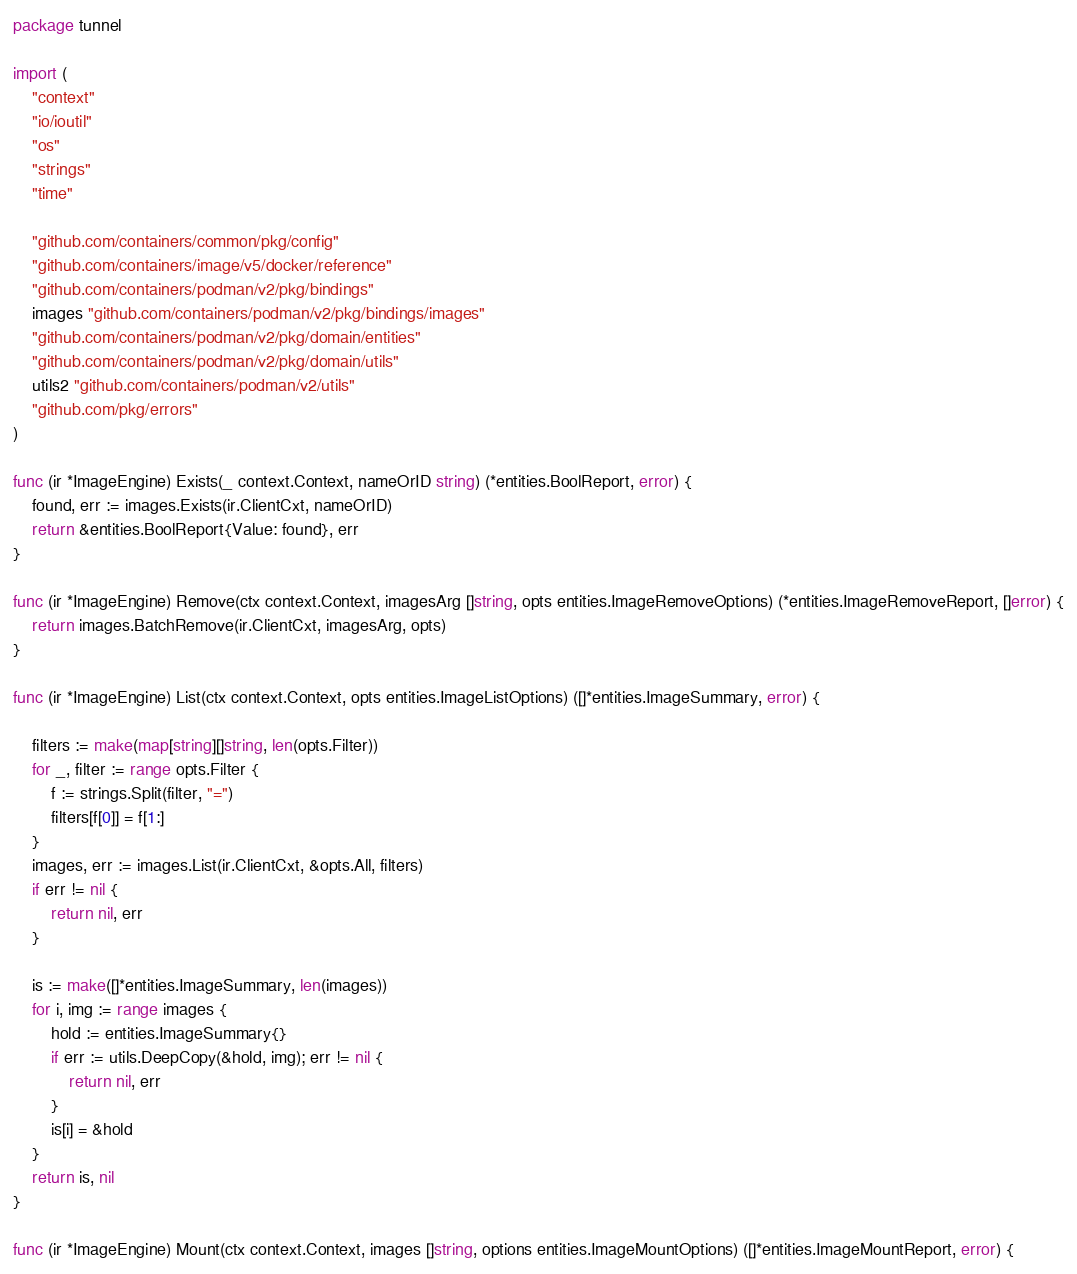<code> <loc_0><loc_0><loc_500><loc_500><_Go_>package tunnel

import (
	"context"
	"io/ioutil"
	"os"
	"strings"
	"time"

	"github.com/containers/common/pkg/config"
	"github.com/containers/image/v5/docker/reference"
	"github.com/containers/podman/v2/pkg/bindings"
	images "github.com/containers/podman/v2/pkg/bindings/images"
	"github.com/containers/podman/v2/pkg/domain/entities"
	"github.com/containers/podman/v2/pkg/domain/utils"
	utils2 "github.com/containers/podman/v2/utils"
	"github.com/pkg/errors"
)

func (ir *ImageEngine) Exists(_ context.Context, nameOrID string) (*entities.BoolReport, error) {
	found, err := images.Exists(ir.ClientCxt, nameOrID)
	return &entities.BoolReport{Value: found}, err
}

func (ir *ImageEngine) Remove(ctx context.Context, imagesArg []string, opts entities.ImageRemoveOptions) (*entities.ImageRemoveReport, []error) {
	return images.BatchRemove(ir.ClientCxt, imagesArg, opts)
}

func (ir *ImageEngine) List(ctx context.Context, opts entities.ImageListOptions) ([]*entities.ImageSummary, error) {

	filters := make(map[string][]string, len(opts.Filter))
	for _, filter := range opts.Filter {
		f := strings.Split(filter, "=")
		filters[f[0]] = f[1:]
	}
	images, err := images.List(ir.ClientCxt, &opts.All, filters)
	if err != nil {
		return nil, err
	}

	is := make([]*entities.ImageSummary, len(images))
	for i, img := range images {
		hold := entities.ImageSummary{}
		if err := utils.DeepCopy(&hold, img); err != nil {
			return nil, err
		}
		is[i] = &hold
	}
	return is, nil
}

func (ir *ImageEngine) Mount(ctx context.Context, images []string, options entities.ImageMountOptions) ([]*entities.ImageMountReport, error) {</code> 